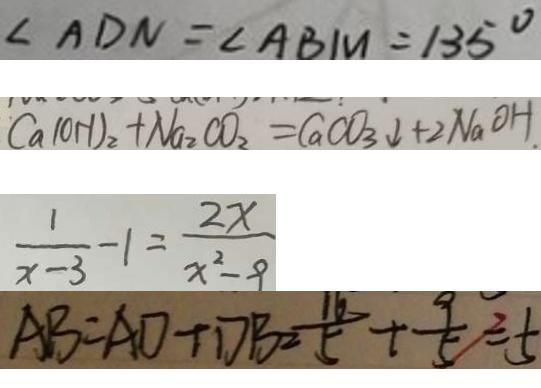Convert formula to latex. <formula><loc_0><loc_0><loc_500><loc_500>\angle A D N = \angle A B M = 1 3 5 ^ { \circ } 
 C a ( O H ) _ { 2 } + N a _ { 2 } C O _ { 2 } = C a C O _ { 3 } \downarrow + 2 N _ { 2 } O H . 
 \frac { 1 } { x - 3 } - 1 = \frac { 2 x } { x ^ { 2 } - 9 } 
 A B = A D + D B = \frac { 1 6 } { 5 } + \frac { 9 } { 5 } = 5</formula> 